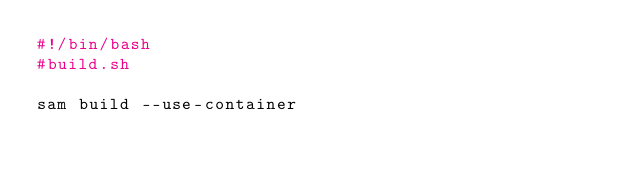<code> <loc_0><loc_0><loc_500><loc_500><_Bash_>#!/bin/bash
#build.sh

sam build --use-container
</code> 